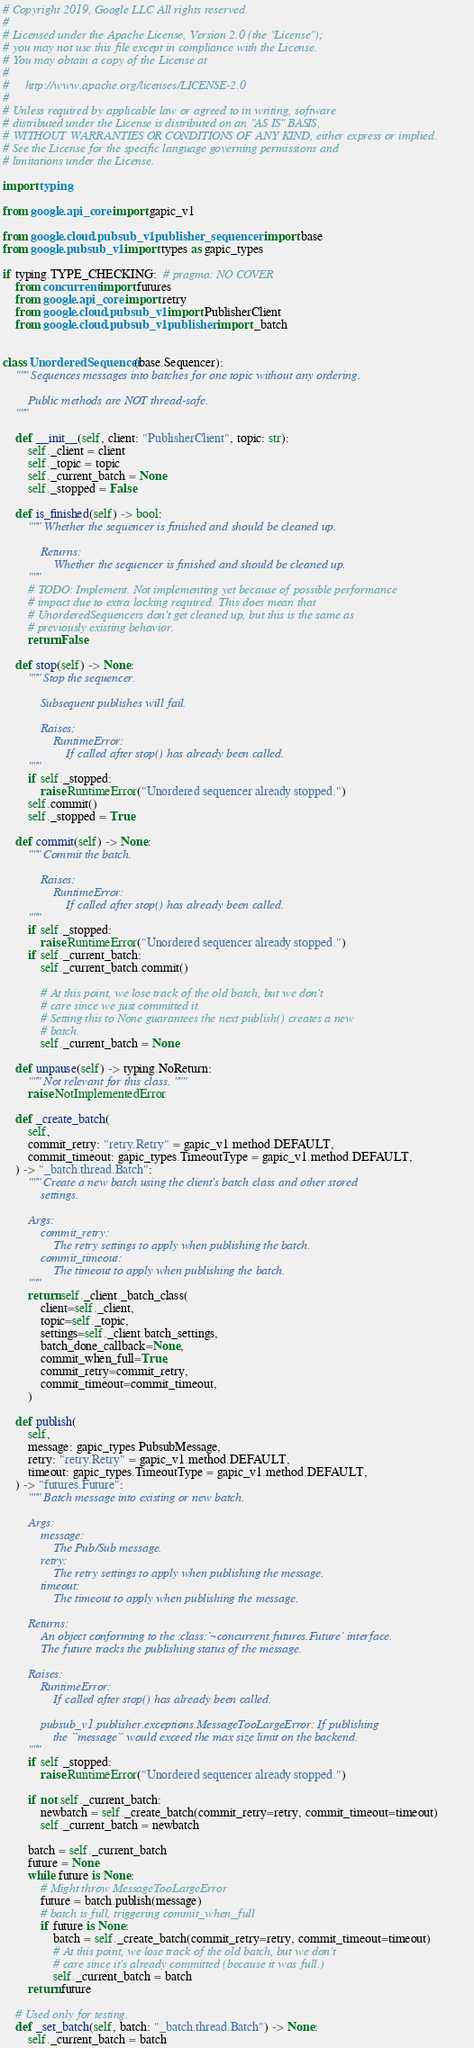Convert code to text. <code><loc_0><loc_0><loc_500><loc_500><_Python_># Copyright 2019, Google LLC All rights reserved.
#
# Licensed under the Apache License, Version 2.0 (the "License");
# you may not use this file except in compliance with the License.
# You may obtain a copy of the License at
#
#     http://www.apache.org/licenses/LICENSE-2.0
#
# Unless required by applicable law or agreed to in writing, software
# distributed under the License is distributed on an "AS IS" BASIS,
# WITHOUT WARRANTIES OR CONDITIONS OF ANY KIND, either express or implied.
# See the License for the specific language governing permissions and
# limitations under the License.

import typing

from google.api_core import gapic_v1

from google.cloud.pubsub_v1.publisher._sequencer import base
from google.pubsub_v1 import types as gapic_types

if typing.TYPE_CHECKING:  # pragma: NO COVER
    from concurrent import futures
    from google.api_core import retry
    from google.cloud.pubsub_v1 import PublisherClient
    from google.cloud.pubsub_v1.publisher import _batch


class UnorderedSequencer(base.Sequencer):
    """ Sequences messages into batches for one topic without any ordering.

        Public methods are NOT thread-safe.
    """

    def __init__(self, client: "PublisherClient", topic: str):
        self._client = client
        self._topic = topic
        self._current_batch = None
        self._stopped = False

    def is_finished(self) -> bool:
        """ Whether the sequencer is finished and should be cleaned up.

            Returns:
                Whether the sequencer is finished and should be cleaned up.
        """
        # TODO: Implement. Not implementing yet because of possible performance
        # impact due to extra locking required. This does mean that
        # UnorderedSequencers don't get cleaned up, but this is the same as
        # previously existing behavior.
        return False

    def stop(self) -> None:
        """ Stop the sequencer.

            Subsequent publishes will fail.

            Raises:
                RuntimeError:
                    If called after stop() has already been called.
        """
        if self._stopped:
            raise RuntimeError("Unordered sequencer already stopped.")
        self.commit()
        self._stopped = True

    def commit(self) -> None:
        """ Commit the batch.

            Raises:
                RuntimeError:
                    If called after stop() has already been called.
        """
        if self._stopped:
            raise RuntimeError("Unordered sequencer already stopped.")
        if self._current_batch:
            self._current_batch.commit()

            # At this point, we lose track of the old batch, but we don't
            # care since we just committed it.
            # Setting this to None guarantees the next publish() creates a new
            # batch.
            self._current_batch = None

    def unpause(self) -> typing.NoReturn:
        """ Not relevant for this class. """
        raise NotImplementedError

    def _create_batch(
        self,
        commit_retry: "retry.Retry" = gapic_v1.method.DEFAULT,
        commit_timeout: gapic_types.TimeoutType = gapic_v1.method.DEFAULT,
    ) -> "_batch.thread.Batch":
        """ Create a new batch using the client's batch class and other stored
            settings.

        Args:
            commit_retry:
                The retry settings to apply when publishing the batch.
            commit_timeout:
                The timeout to apply when publishing the batch.
        """
        return self._client._batch_class(
            client=self._client,
            topic=self._topic,
            settings=self._client.batch_settings,
            batch_done_callback=None,
            commit_when_full=True,
            commit_retry=commit_retry,
            commit_timeout=commit_timeout,
        )

    def publish(
        self,
        message: gapic_types.PubsubMessage,
        retry: "retry.Retry" = gapic_v1.method.DEFAULT,
        timeout: gapic_types.TimeoutType = gapic_v1.method.DEFAULT,
    ) -> "futures.Future":
        """ Batch message into existing or new batch.

        Args:
            message:
                The Pub/Sub message.
            retry:
                The retry settings to apply when publishing the message.
            timeout:
                The timeout to apply when publishing the message.

        Returns:
            An object conforming to the :class:`~concurrent.futures.Future` interface.
            The future tracks the publishing status of the message.

        Raises:
            RuntimeError:
                If called after stop() has already been called.

            pubsub_v1.publisher.exceptions.MessageTooLargeError: If publishing
                the ``message`` would exceed the max size limit on the backend.
        """
        if self._stopped:
            raise RuntimeError("Unordered sequencer already stopped.")

        if not self._current_batch:
            newbatch = self._create_batch(commit_retry=retry, commit_timeout=timeout)
            self._current_batch = newbatch

        batch = self._current_batch
        future = None
        while future is None:
            # Might throw MessageTooLargeError
            future = batch.publish(message)
            # batch is full, triggering commit_when_full
            if future is None:
                batch = self._create_batch(commit_retry=retry, commit_timeout=timeout)
                # At this point, we lose track of the old batch, but we don't
                # care since it's already committed (because it was full.)
                self._current_batch = batch
        return future

    # Used only for testing.
    def _set_batch(self, batch: "_batch.thread.Batch") -> None:
        self._current_batch = batch
</code> 